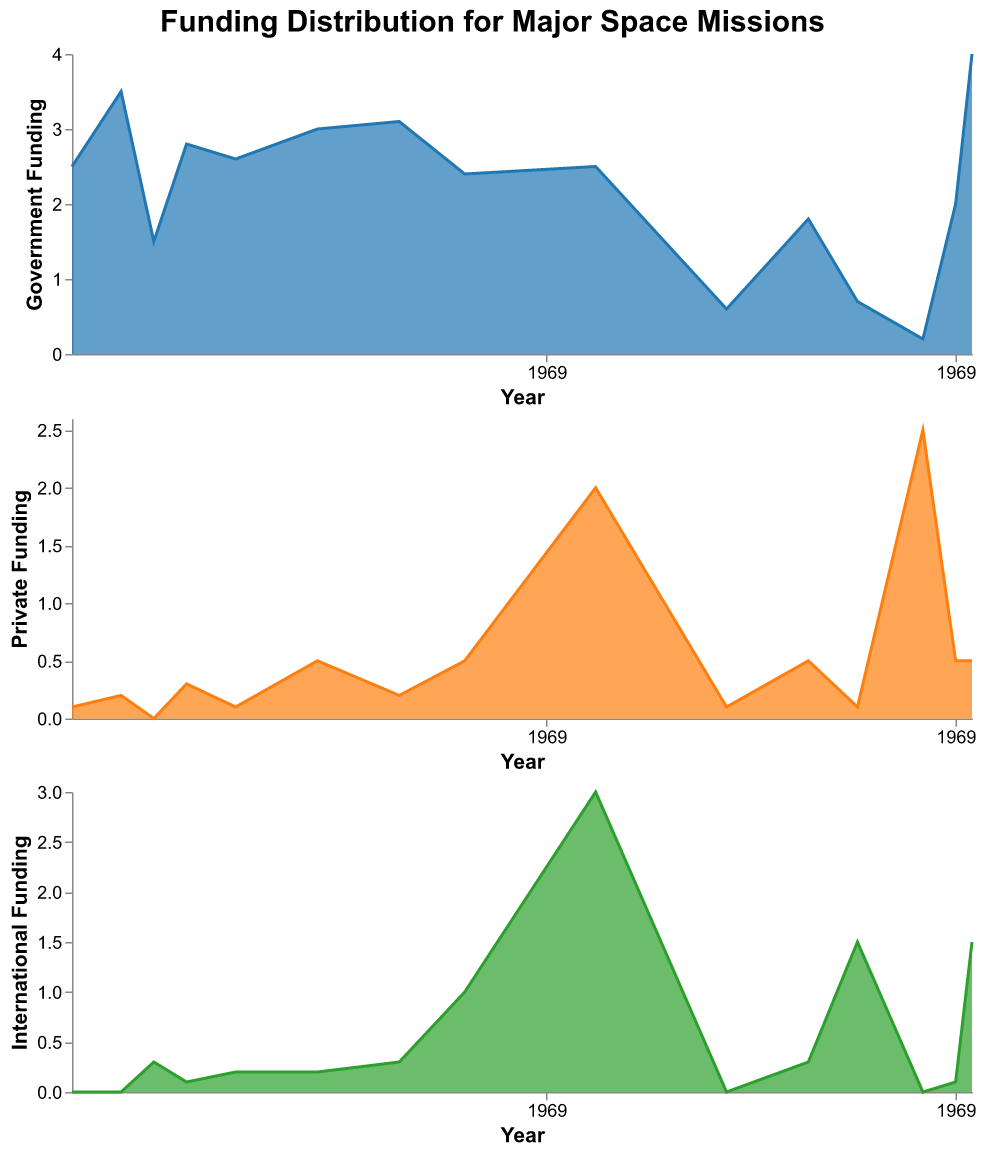How much government funding was allocated to the Apollo Program (USA) in 1966? The area chart on government funding shows the different missions and their respective funding amounts over time. For the year 1966, the Apollo Program (USA) received the funding. Referencing the government funding area chart, it's evident that the Apollo Program (USA) received government funding of 2.5 units.
Answer: 2.5 Which mission received the highest amount of private funding in the dataset? Observing the private funding area chart, we can see all the missions and their corresponding private funding over time. The mission with the highest private funding appears to be Falcon Heavy (USA) in 2018.
Answer: Falcon Heavy (USA) Describe the trend in international funding for major space missions from 1990 onwards. By analyzing the international funding area chart, there's a noticeable spike in 1990 for the Hubble Space Telescope, followed by another significant peak in 1998 for the ISS. Subsequently, international funding sees a rise in 2014 for Philae/Rosetta (ESA) and peaks dramatically in 2021 for the James Webb Space Telescope.
Answer: Increase with significant peaks in 1990, 1998, 2014, and 2021 Compare the government funding for the Apollo Program (USA) in 1969 and the James Webb Space Telescope (International) in 2021. Which was greater and by how much? From the government funding area chart, in 1969, the Apollo Program (USA) received 3.5 units of government funding, while in 2021, the James Webb Space Telescope (International) received 4.0 units. The James Webb Space Telescope had more funding by 0.5 units.
Answer: James Webb Space Telescope; 0.5 units Which mission had the highest international funding, and in what year did it occur? In the international funding area chart, the highest peak is for the ISS (International) in 1998, with international funding of 3.0 units.
Answer: ISS (International), 1998 Identify the mission that marked a significant increase in private funding in 2018. In the private funding area chart, there's a noticeable spike in 2018. This spike corresponds to Falcon Heavy (USA), indicating a significant rise in private funding.
Answer: Falcon Heavy (USA) Was there any international funding for the Apollo Program (USA)? Referring to the international funding area chart, it's clear that there were no international funds allocated to the Apollo Program (USA) at any time.
Answer: No Calculate the total government funding for space missions in the year 1973. Examining the government funding area chart, we see that in 1973, the Skylab (USA) mission received 2.8 units of government funding. Since there are no other missions listed for 1973, the total government funding for that year is 2.8 units.
Answer: 2.8 units Which mission showed a balanced mix of government, private, and international funding in 1990? By looking at all three area charts for the year 1990, the Hubble Space Telescope received a mix of 2.4 units in government funding, 0.5 units in private funding, and 1.0 units in international funding. This indicates a balanced funding mix from these sources.
Answer: Hubble Space Telescope How does the funding distribution for the ISS (International) in 1998 compare across all three sources (government, private, and international)? In 1998, the ISS received 2.5 units in government funding, 2.0 units in private funding, and 3.0 units in international funding, making it one of the few missions with a substantial distribution across all three sources.
Answer: 2.5 (Government), 2.0 (Private), 3.0 (International) 